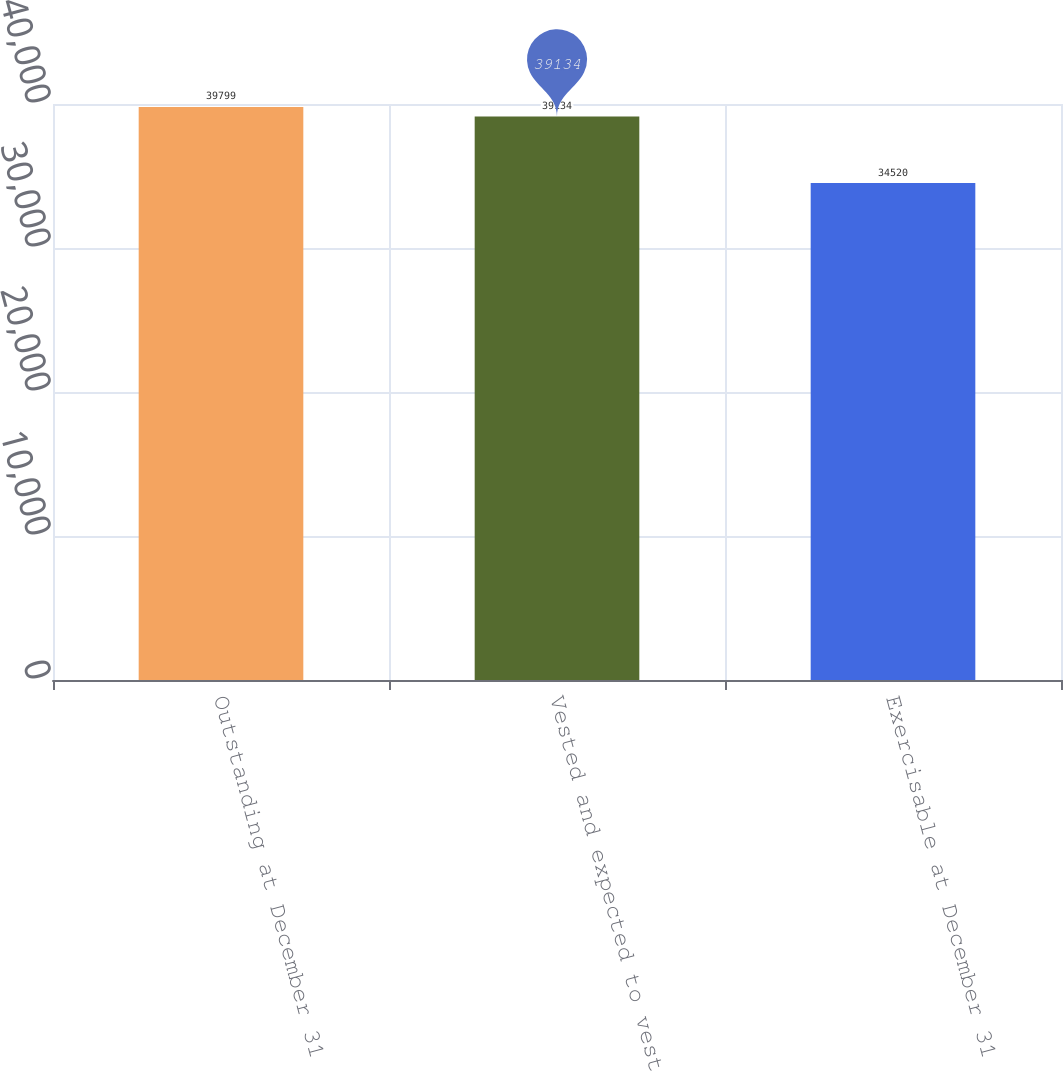Convert chart. <chart><loc_0><loc_0><loc_500><loc_500><bar_chart><fcel>Outstanding at December 31<fcel>Vested and expected to vest<fcel>Exercisable at December 31<nl><fcel>39799<fcel>39134<fcel>34520<nl></chart> 